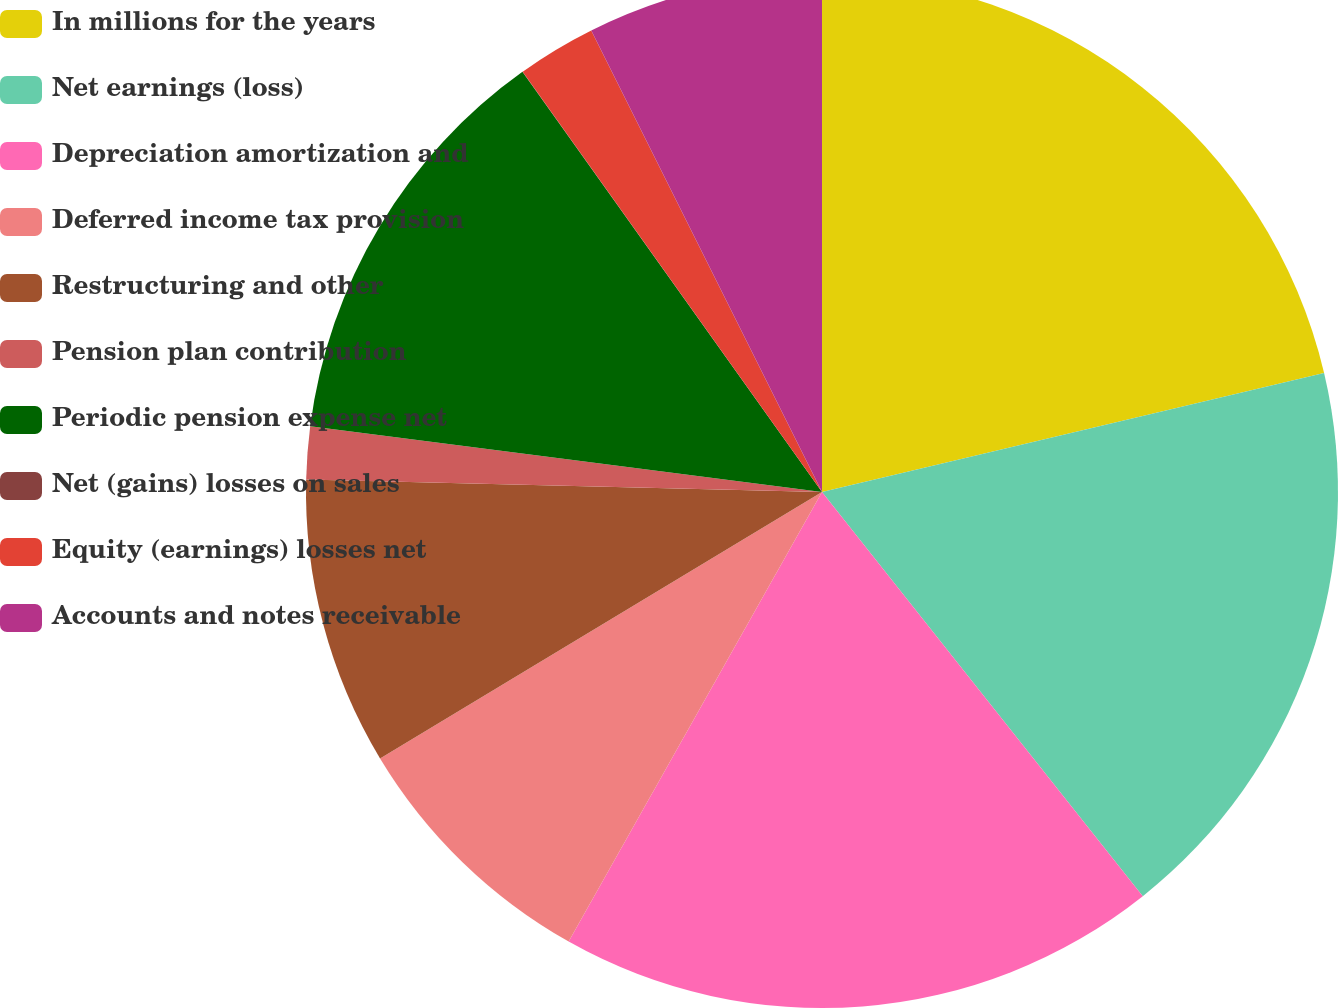Convert chart. <chart><loc_0><loc_0><loc_500><loc_500><pie_chart><fcel>In millions for the years<fcel>Net earnings (loss)<fcel>Depreciation amortization and<fcel>Deferred income tax provision<fcel>Restructuring and other<fcel>Pension plan contribution<fcel>Periodic pension expense net<fcel>Net (gains) losses on sales<fcel>Equity (earnings) losses net<fcel>Accounts and notes receivable<nl><fcel>21.3%<fcel>18.03%<fcel>18.85%<fcel>8.2%<fcel>9.02%<fcel>1.65%<fcel>13.11%<fcel>0.01%<fcel>2.47%<fcel>7.38%<nl></chart> 